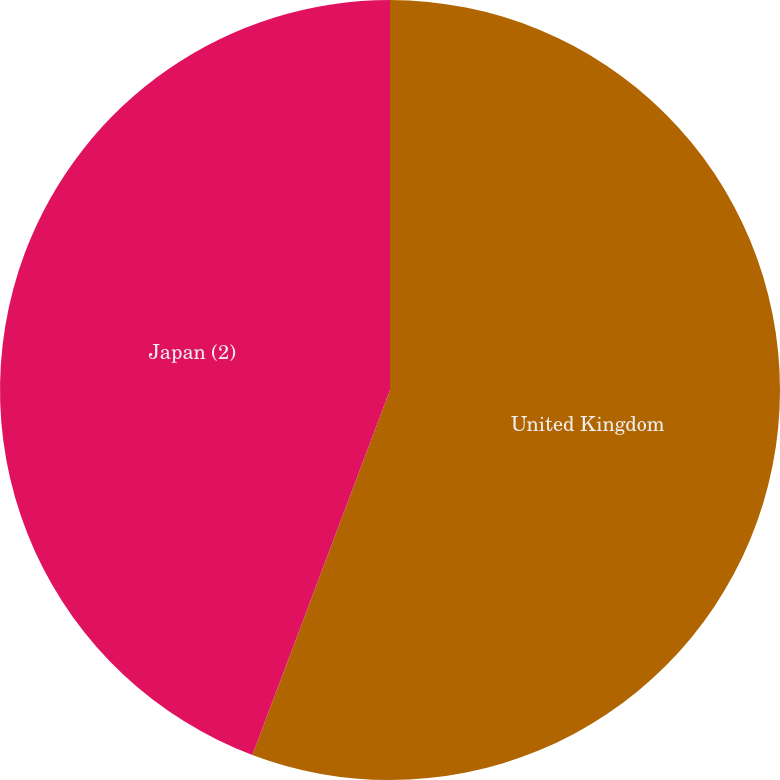<chart> <loc_0><loc_0><loc_500><loc_500><pie_chart><fcel>United Kingdom<fcel>Japan (2)<nl><fcel>55.74%<fcel>44.26%<nl></chart> 